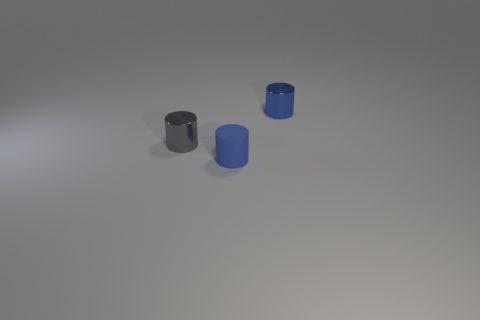Add 2 small metal objects. How many objects exist? 5 Subtract all cylinders. Subtract all large cylinders. How many objects are left? 0 Add 3 small matte cylinders. How many small matte cylinders are left? 4 Add 2 green objects. How many green objects exist? 2 Subtract 0 purple spheres. How many objects are left? 3 